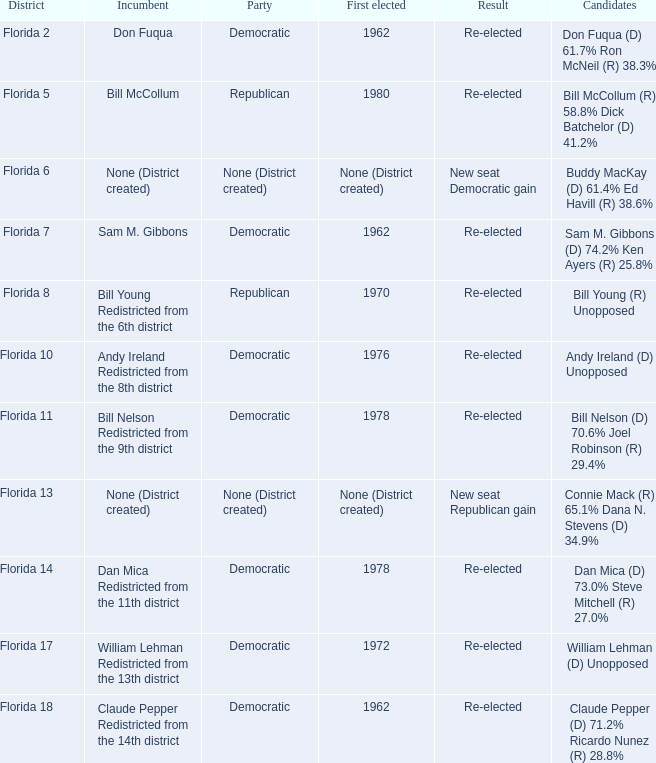In florida's 7th district, what was the first elected post? 1962.0. 